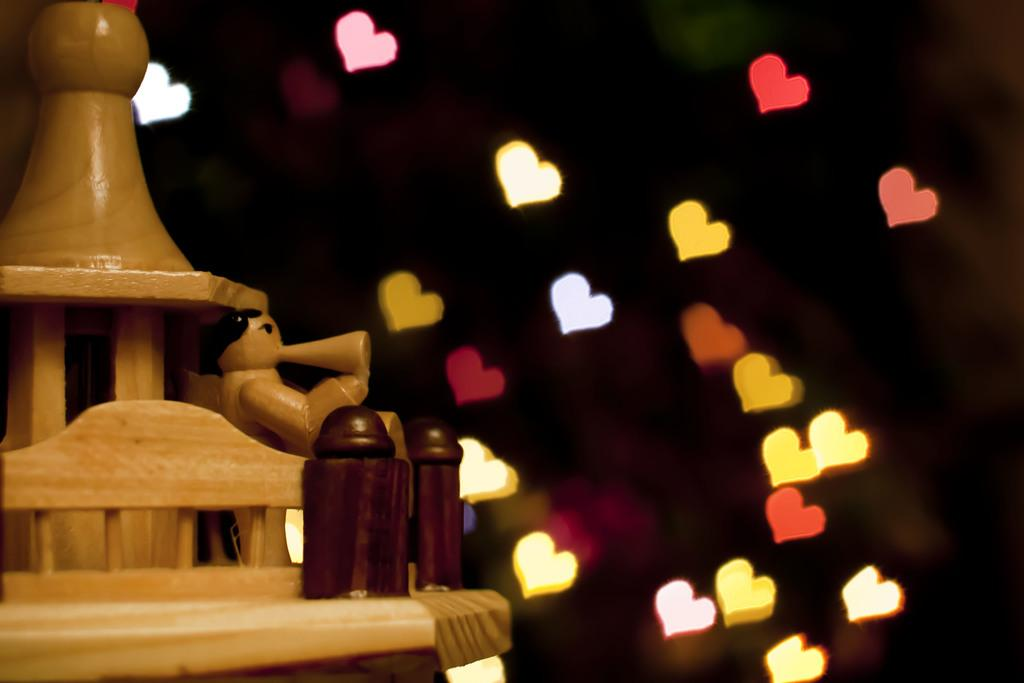What type of toy is in the image? There is a wooden toy in the image. Where is the wooden toy located in the image? The wooden toy is towards the left side of the image. What type of lights are in the image? There are heart-shaped lights in the image. Where are the heart-shaped lights located in the image? The heart-shaped lights are towards the right side of the image. What type of trouble does the wooden toy cause for the passenger in the image? There is no passenger present in the image, and the wooden toy does not cause any trouble. 